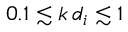Convert formula to latex. <formula><loc_0><loc_0><loc_500><loc_500>0 . 1 \lesssim k \, d _ { i } \lesssim 1</formula> 